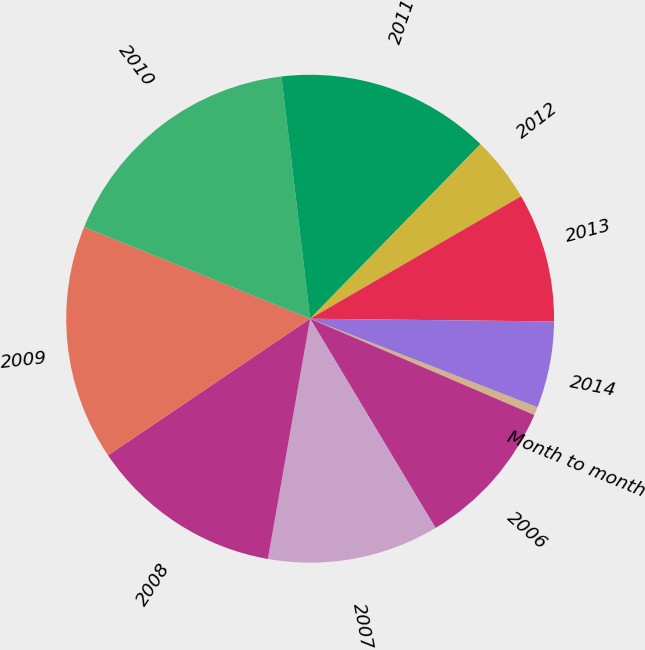Convert chart to OTSL. <chart><loc_0><loc_0><loc_500><loc_500><pie_chart><fcel>Month to month<fcel>2006<fcel>2007<fcel>2008<fcel>2009<fcel>2010<fcel>2011<fcel>2012<fcel>2013<fcel>2014<nl><fcel>0.55%<fcel>9.95%<fcel>11.36%<fcel>12.77%<fcel>15.59%<fcel>16.99%<fcel>14.18%<fcel>4.32%<fcel>8.55%<fcel>5.73%<nl></chart> 